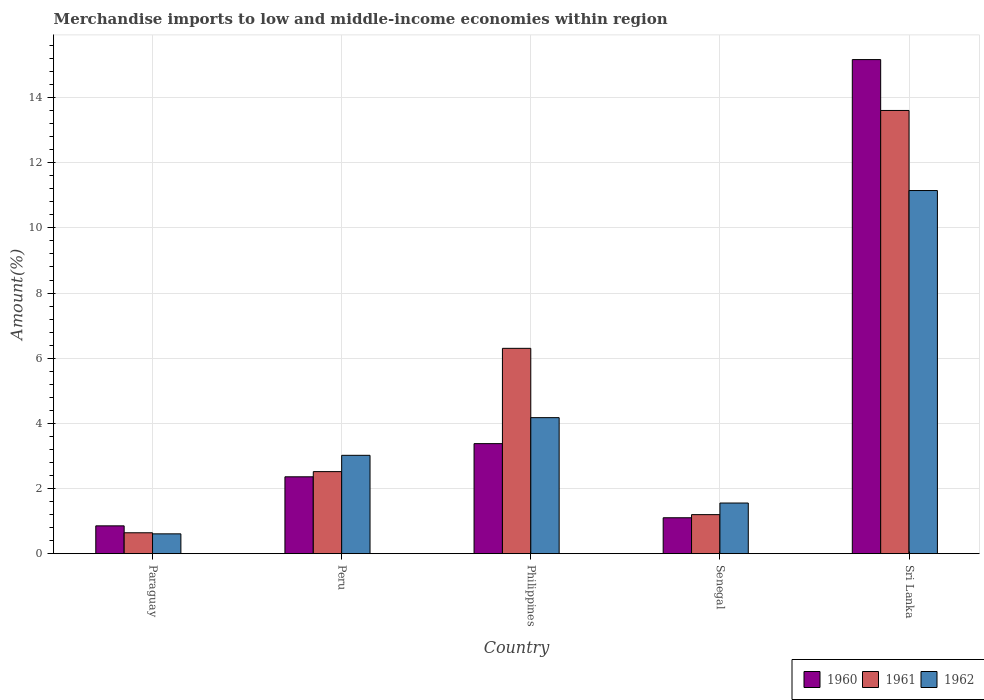How many different coloured bars are there?
Your answer should be compact. 3. Are the number of bars per tick equal to the number of legend labels?
Give a very brief answer. Yes. Are the number of bars on each tick of the X-axis equal?
Offer a very short reply. Yes. How many bars are there on the 5th tick from the right?
Provide a succinct answer. 3. What is the label of the 1st group of bars from the left?
Offer a terse response. Paraguay. What is the percentage of amount earned from merchandise imports in 1960 in Senegal?
Your answer should be very brief. 1.1. Across all countries, what is the maximum percentage of amount earned from merchandise imports in 1960?
Your response must be concise. 15.17. Across all countries, what is the minimum percentage of amount earned from merchandise imports in 1962?
Offer a terse response. 0.61. In which country was the percentage of amount earned from merchandise imports in 1962 maximum?
Provide a short and direct response. Sri Lanka. In which country was the percentage of amount earned from merchandise imports in 1961 minimum?
Offer a very short reply. Paraguay. What is the total percentage of amount earned from merchandise imports in 1962 in the graph?
Your answer should be very brief. 20.5. What is the difference between the percentage of amount earned from merchandise imports in 1961 in Paraguay and that in Philippines?
Offer a very short reply. -5.66. What is the difference between the percentage of amount earned from merchandise imports in 1960 in Senegal and the percentage of amount earned from merchandise imports in 1962 in Paraguay?
Keep it short and to the point. 0.49. What is the average percentage of amount earned from merchandise imports in 1962 per country?
Ensure brevity in your answer.  4.1. What is the difference between the percentage of amount earned from merchandise imports of/in 1961 and percentage of amount earned from merchandise imports of/in 1960 in Senegal?
Give a very brief answer. 0.1. In how many countries, is the percentage of amount earned from merchandise imports in 1960 greater than 1.2000000000000002 %?
Offer a terse response. 3. What is the ratio of the percentage of amount earned from merchandise imports in 1962 in Philippines to that in Sri Lanka?
Offer a terse response. 0.37. Is the percentage of amount earned from merchandise imports in 1961 in Philippines less than that in Sri Lanka?
Give a very brief answer. Yes. What is the difference between the highest and the second highest percentage of amount earned from merchandise imports in 1961?
Offer a very short reply. -11.09. What is the difference between the highest and the lowest percentage of amount earned from merchandise imports in 1960?
Ensure brevity in your answer.  14.31. In how many countries, is the percentage of amount earned from merchandise imports in 1962 greater than the average percentage of amount earned from merchandise imports in 1962 taken over all countries?
Keep it short and to the point. 2. What does the 2nd bar from the left in Philippines represents?
Ensure brevity in your answer.  1961. Is it the case that in every country, the sum of the percentage of amount earned from merchandise imports in 1962 and percentage of amount earned from merchandise imports in 1960 is greater than the percentage of amount earned from merchandise imports in 1961?
Your answer should be compact. Yes. Are all the bars in the graph horizontal?
Provide a succinct answer. No. How many countries are there in the graph?
Your answer should be very brief. 5. Are the values on the major ticks of Y-axis written in scientific E-notation?
Provide a short and direct response. No. Does the graph contain grids?
Offer a very short reply. Yes. How many legend labels are there?
Provide a succinct answer. 3. How are the legend labels stacked?
Provide a short and direct response. Horizontal. What is the title of the graph?
Offer a terse response. Merchandise imports to low and middle-income economies within region. Does "1972" appear as one of the legend labels in the graph?
Your response must be concise. No. What is the label or title of the Y-axis?
Make the answer very short. Amount(%). What is the Amount(%) in 1960 in Paraguay?
Make the answer very short. 0.85. What is the Amount(%) in 1961 in Paraguay?
Provide a succinct answer. 0.64. What is the Amount(%) of 1962 in Paraguay?
Give a very brief answer. 0.61. What is the Amount(%) of 1960 in Peru?
Ensure brevity in your answer.  2.36. What is the Amount(%) in 1961 in Peru?
Your answer should be compact. 2.52. What is the Amount(%) in 1962 in Peru?
Ensure brevity in your answer.  3.02. What is the Amount(%) in 1960 in Philippines?
Make the answer very short. 3.38. What is the Amount(%) of 1961 in Philippines?
Offer a very short reply. 6.3. What is the Amount(%) of 1962 in Philippines?
Make the answer very short. 4.18. What is the Amount(%) in 1960 in Senegal?
Offer a very short reply. 1.1. What is the Amount(%) in 1961 in Senegal?
Offer a terse response. 1.2. What is the Amount(%) in 1962 in Senegal?
Make the answer very short. 1.55. What is the Amount(%) in 1960 in Sri Lanka?
Ensure brevity in your answer.  15.17. What is the Amount(%) in 1961 in Sri Lanka?
Offer a terse response. 13.6. What is the Amount(%) in 1962 in Sri Lanka?
Ensure brevity in your answer.  11.15. Across all countries, what is the maximum Amount(%) in 1960?
Give a very brief answer. 15.17. Across all countries, what is the maximum Amount(%) of 1961?
Offer a terse response. 13.6. Across all countries, what is the maximum Amount(%) in 1962?
Offer a very short reply. 11.15. Across all countries, what is the minimum Amount(%) of 1960?
Keep it short and to the point. 0.85. Across all countries, what is the minimum Amount(%) of 1961?
Your answer should be compact. 0.64. Across all countries, what is the minimum Amount(%) of 1962?
Your answer should be compact. 0.61. What is the total Amount(%) of 1960 in the graph?
Your answer should be compact. 22.86. What is the total Amount(%) in 1961 in the graph?
Your answer should be compact. 24.26. What is the total Amount(%) of 1962 in the graph?
Keep it short and to the point. 20.5. What is the difference between the Amount(%) in 1960 in Paraguay and that in Peru?
Your answer should be compact. -1.51. What is the difference between the Amount(%) in 1961 in Paraguay and that in Peru?
Make the answer very short. -1.88. What is the difference between the Amount(%) of 1962 in Paraguay and that in Peru?
Provide a short and direct response. -2.41. What is the difference between the Amount(%) of 1960 in Paraguay and that in Philippines?
Give a very brief answer. -2.52. What is the difference between the Amount(%) in 1961 in Paraguay and that in Philippines?
Provide a succinct answer. -5.66. What is the difference between the Amount(%) of 1962 in Paraguay and that in Philippines?
Your answer should be very brief. -3.57. What is the difference between the Amount(%) in 1960 in Paraguay and that in Senegal?
Keep it short and to the point. -0.25. What is the difference between the Amount(%) in 1961 in Paraguay and that in Senegal?
Make the answer very short. -0.56. What is the difference between the Amount(%) of 1962 in Paraguay and that in Senegal?
Make the answer very short. -0.95. What is the difference between the Amount(%) of 1960 in Paraguay and that in Sri Lanka?
Your response must be concise. -14.31. What is the difference between the Amount(%) of 1961 in Paraguay and that in Sri Lanka?
Give a very brief answer. -12.96. What is the difference between the Amount(%) of 1962 in Paraguay and that in Sri Lanka?
Provide a short and direct response. -10.54. What is the difference between the Amount(%) in 1960 in Peru and that in Philippines?
Your response must be concise. -1.02. What is the difference between the Amount(%) in 1961 in Peru and that in Philippines?
Ensure brevity in your answer.  -3.78. What is the difference between the Amount(%) in 1962 in Peru and that in Philippines?
Offer a very short reply. -1.16. What is the difference between the Amount(%) in 1960 in Peru and that in Senegal?
Offer a very short reply. 1.26. What is the difference between the Amount(%) of 1961 in Peru and that in Senegal?
Offer a terse response. 1.32. What is the difference between the Amount(%) in 1962 in Peru and that in Senegal?
Your answer should be very brief. 1.46. What is the difference between the Amount(%) of 1960 in Peru and that in Sri Lanka?
Offer a terse response. -12.81. What is the difference between the Amount(%) of 1961 in Peru and that in Sri Lanka?
Your response must be concise. -11.09. What is the difference between the Amount(%) of 1962 in Peru and that in Sri Lanka?
Make the answer very short. -8.13. What is the difference between the Amount(%) in 1960 in Philippines and that in Senegal?
Your response must be concise. 2.28. What is the difference between the Amount(%) of 1961 in Philippines and that in Senegal?
Keep it short and to the point. 5.1. What is the difference between the Amount(%) in 1962 in Philippines and that in Senegal?
Provide a succinct answer. 2.62. What is the difference between the Amount(%) of 1960 in Philippines and that in Sri Lanka?
Your response must be concise. -11.79. What is the difference between the Amount(%) of 1961 in Philippines and that in Sri Lanka?
Give a very brief answer. -7.3. What is the difference between the Amount(%) of 1962 in Philippines and that in Sri Lanka?
Offer a terse response. -6.97. What is the difference between the Amount(%) of 1960 in Senegal and that in Sri Lanka?
Offer a terse response. -14.06. What is the difference between the Amount(%) of 1961 in Senegal and that in Sri Lanka?
Offer a terse response. -12.41. What is the difference between the Amount(%) of 1962 in Senegal and that in Sri Lanka?
Provide a short and direct response. -9.59. What is the difference between the Amount(%) of 1960 in Paraguay and the Amount(%) of 1961 in Peru?
Offer a terse response. -1.66. What is the difference between the Amount(%) of 1960 in Paraguay and the Amount(%) of 1962 in Peru?
Your answer should be very brief. -2.17. What is the difference between the Amount(%) in 1961 in Paraguay and the Amount(%) in 1962 in Peru?
Offer a very short reply. -2.38. What is the difference between the Amount(%) of 1960 in Paraguay and the Amount(%) of 1961 in Philippines?
Offer a terse response. -5.45. What is the difference between the Amount(%) in 1960 in Paraguay and the Amount(%) in 1962 in Philippines?
Provide a succinct answer. -3.32. What is the difference between the Amount(%) of 1961 in Paraguay and the Amount(%) of 1962 in Philippines?
Ensure brevity in your answer.  -3.53. What is the difference between the Amount(%) in 1960 in Paraguay and the Amount(%) in 1961 in Senegal?
Your response must be concise. -0.34. What is the difference between the Amount(%) of 1960 in Paraguay and the Amount(%) of 1962 in Senegal?
Ensure brevity in your answer.  -0.7. What is the difference between the Amount(%) of 1961 in Paraguay and the Amount(%) of 1962 in Senegal?
Provide a short and direct response. -0.91. What is the difference between the Amount(%) of 1960 in Paraguay and the Amount(%) of 1961 in Sri Lanka?
Ensure brevity in your answer.  -12.75. What is the difference between the Amount(%) of 1960 in Paraguay and the Amount(%) of 1962 in Sri Lanka?
Give a very brief answer. -10.29. What is the difference between the Amount(%) in 1961 in Paraguay and the Amount(%) in 1962 in Sri Lanka?
Offer a very short reply. -10.51. What is the difference between the Amount(%) in 1960 in Peru and the Amount(%) in 1961 in Philippines?
Give a very brief answer. -3.94. What is the difference between the Amount(%) of 1960 in Peru and the Amount(%) of 1962 in Philippines?
Keep it short and to the point. -1.82. What is the difference between the Amount(%) of 1961 in Peru and the Amount(%) of 1962 in Philippines?
Give a very brief answer. -1.66. What is the difference between the Amount(%) of 1960 in Peru and the Amount(%) of 1961 in Senegal?
Your response must be concise. 1.16. What is the difference between the Amount(%) of 1960 in Peru and the Amount(%) of 1962 in Senegal?
Provide a short and direct response. 0.8. What is the difference between the Amount(%) in 1961 in Peru and the Amount(%) in 1962 in Senegal?
Provide a succinct answer. 0.96. What is the difference between the Amount(%) in 1960 in Peru and the Amount(%) in 1961 in Sri Lanka?
Your answer should be very brief. -11.24. What is the difference between the Amount(%) of 1960 in Peru and the Amount(%) of 1962 in Sri Lanka?
Make the answer very short. -8.79. What is the difference between the Amount(%) of 1961 in Peru and the Amount(%) of 1962 in Sri Lanka?
Your response must be concise. -8.63. What is the difference between the Amount(%) of 1960 in Philippines and the Amount(%) of 1961 in Senegal?
Your answer should be very brief. 2.18. What is the difference between the Amount(%) in 1960 in Philippines and the Amount(%) in 1962 in Senegal?
Ensure brevity in your answer.  1.82. What is the difference between the Amount(%) in 1961 in Philippines and the Amount(%) in 1962 in Senegal?
Your response must be concise. 4.75. What is the difference between the Amount(%) of 1960 in Philippines and the Amount(%) of 1961 in Sri Lanka?
Offer a terse response. -10.23. What is the difference between the Amount(%) in 1960 in Philippines and the Amount(%) in 1962 in Sri Lanka?
Your answer should be compact. -7.77. What is the difference between the Amount(%) of 1961 in Philippines and the Amount(%) of 1962 in Sri Lanka?
Your answer should be compact. -4.84. What is the difference between the Amount(%) of 1960 in Senegal and the Amount(%) of 1961 in Sri Lanka?
Your answer should be compact. -12.5. What is the difference between the Amount(%) of 1960 in Senegal and the Amount(%) of 1962 in Sri Lanka?
Make the answer very short. -10.04. What is the difference between the Amount(%) of 1961 in Senegal and the Amount(%) of 1962 in Sri Lanka?
Your answer should be very brief. -9.95. What is the average Amount(%) in 1960 per country?
Ensure brevity in your answer.  4.57. What is the average Amount(%) in 1961 per country?
Make the answer very short. 4.85. What is the average Amount(%) in 1962 per country?
Provide a short and direct response. 4.1. What is the difference between the Amount(%) in 1960 and Amount(%) in 1961 in Paraguay?
Provide a short and direct response. 0.21. What is the difference between the Amount(%) of 1960 and Amount(%) of 1962 in Paraguay?
Give a very brief answer. 0.25. What is the difference between the Amount(%) of 1961 and Amount(%) of 1962 in Paraguay?
Make the answer very short. 0.03. What is the difference between the Amount(%) of 1960 and Amount(%) of 1961 in Peru?
Your answer should be compact. -0.16. What is the difference between the Amount(%) in 1960 and Amount(%) in 1962 in Peru?
Give a very brief answer. -0.66. What is the difference between the Amount(%) in 1961 and Amount(%) in 1962 in Peru?
Your answer should be very brief. -0.5. What is the difference between the Amount(%) of 1960 and Amount(%) of 1961 in Philippines?
Ensure brevity in your answer.  -2.93. What is the difference between the Amount(%) in 1960 and Amount(%) in 1962 in Philippines?
Keep it short and to the point. -0.8. What is the difference between the Amount(%) of 1961 and Amount(%) of 1962 in Philippines?
Ensure brevity in your answer.  2.13. What is the difference between the Amount(%) in 1960 and Amount(%) in 1961 in Senegal?
Your answer should be very brief. -0.1. What is the difference between the Amount(%) in 1960 and Amount(%) in 1962 in Senegal?
Provide a short and direct response. -0.45. What is the difference between the Amount(%) of 1961 and Amount(%) of 1962 in Senegal?
Your answer should be very brief. -0.36. What is the difference between the Amount(%) in 1960 and Amount(%) in 1961 in Sri Lanka?
Make the answer very short. 1.56. What is the difference between the Amount(%) of 1960 and Amount(%) of 1962 in Sri Lanka?
Your answer should be compact. 4.02. What is the difference between the Amount(%) of 1961 and Amount(%) of 1962 in Sri Lanka?
Offer a very short reply. 2.46. What is the ratio of the Amount(%) in 1960 in Paraguay to that in Peru?
Provide a succinct answer. 0.36. What is the ratio of the Amount(%) of 1961 in Paraguay to that in Peru?
Your answer should be very brief. 0.25. What is the ratio of the Amount(%) of 1962 in Paraguay to that in Peru?
Your answer should be very brief. 0.2. What is the ratio of the Amount(%) of 1960 in Paraguay to that in Philippines?
Provide a succinct answer. 0.25. What is the ratio of the Amount(%) of 1961 in Paraguay to that in Philippines?
Ensure brevity in your answer.  0.1. What is the ratio of the Amount(%) of 1962 in Paraguay to that in Philippines?
Offer a terse response. 0.15. What is the ratio of the Amount(%) in 1960 in Paraguay to that in Senegal?
Ensure brevity in your answer.  0.77. What is the ratio of the Amount(%) of 1961 in Paraguay to that in Senegal?
Your answer should be compact. 0.54. What is the ratio of the Amount(%) of 1962 in Paraguay to that in Senegal?
Your answer should be very brief. 0.39. What is the ratio of the Amount(%) of 1960 in Paraguay to that in Sri Lanka?
Give a very brief answer. 0.06. What is the ratio of the Amount(%) of 1961 in Paraguay to that in Sri Lanka?
Offer a terse response. 0.05. What is the ratio of the Amount(%) of 1962 in Paraguay to that in Sri Lanka?
Give a very brief answer. 0.05. What is the ratio of the Amount(%) in 1960 in Peru to that in Philippines?
Your answer should be very brief. 0.7. What is the ratio of the Amount(%) of 1961 in Peru to that in Philippines?
Give a very brief answer. 0.4. What is the ratio of the Amount(%) of 1962 in Peru to that in Philippines?
Provide a succinct answer. 0.72. What is the ratio of the Amount(%) of 1960 in Peru to that in Senegal?
Make the answer very short. 2.14. What is the ratio of the Amount(%) in 1961 in Peru to that in Senegal?
Give a very brief answer. 2.1. What is the ratio of the Amount(%) in 1962 in Peru to that in Senegal?
Your answer should be compact. 1.94. What is the ratio of the Amount(%) of 1960 in Peru to that in Sri Lanka?
Make the answer very short. 0.16. What is the ratio of the Amount(%) of 1961 in Peru to that in Sri Lanka?
Your answer should be compact. 0.19. What is the ratio of the Amount(%) in 1962 in Peru to that in Sri Lanka?
Your response must be concise. 0.27. What is the ratio of the Amount(%) in 1960 in Philippines to that in Senegal?
Make the answer very short. 3.06. What is the ratio of the Amount(%) in 1961 in Philippines to that in Senegal?
Your answer should be compact. 5.26. What is the ratio of the Amount(%) in 1962 in Philippines to that in Senegal?
Your response must be concise. 2.69. What is the ratio of the Amount(%) in 1960 in Philippines to that in Sri Lanka?
Your answer should be compact. 0.22. What is the ratio of the Amount(%) in 1961 in Philippines to that in Sri Lanka?
Offer a very short reply. 0.46. What is the ratio of the Amount(%) in 1962 in Philippines to that in Sri Lanka?
Provide a short and direct response. 0.37. What is the ratio of the Amount(%) in 1960 in Senegal to that in Sri Lanka?
Your response must be concise. 0.07. What is the ratio of the Amount(%) of 1961 in Senegal to that in Sri Lanka?
Give a very brief answer. 0.09. What is the ratio of the Amount(%) in 1962 in Senegal to that in Sri Lanka?
Provide a succinct answer. 0.14. What is the difference between the highest and the second highest Amount(%) in 1960?
Offer a terse response. 11.79. What is the difference between the highest and the second highest Amount(%) of 1961?
Ensure brevity in your answer.  7.3. What is the difference between the highest and the second highest Amount(%) in 1962?
Offer a terse response. 6.97. What is the difference between the highest and the lowest Amount(%) in 1960?
Give a very brief answer. 14.31. What is the difference between the highest and the lowest Amount(%) in 1961?
Provide a short and direct response. 12.96. What is the difference between the highest and the lowest Amount(%) of 1962?
Make the answer very short. 10.54. 